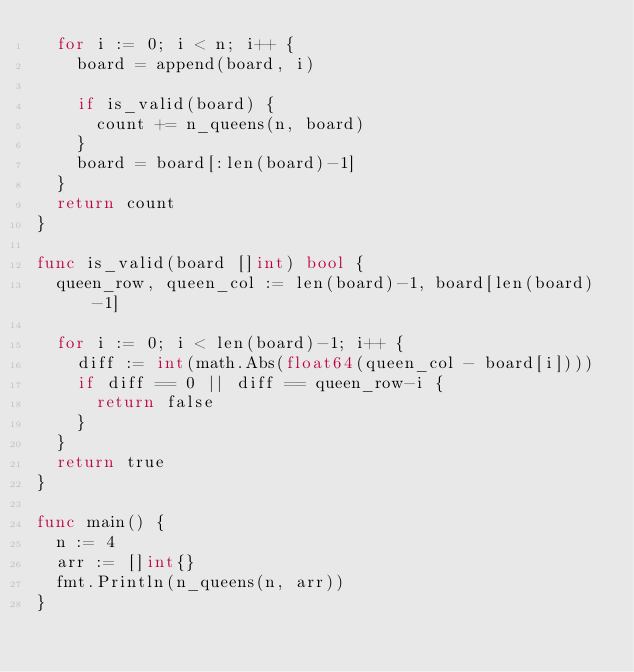<code> <loc_0><loc_0><loc_500><loc_500><_Go_>	for i := 0; i < n; i++ {
		board = append(board, i)

		if is_valid(board) {
			count += n_queens(n, board)
		}
		board = board[:len(board)-1]
	}
	return count
}

func is_valid(board []int) bool {
	queen_row, queen_col := len(board)-1, board[len(board)-1]

	for i := 0; i < len(board)-1; i++ {
		diff := int(math.Abs(float64(queen_col - board[i])))
		if diff == 0 || diff == queen_row-i {
			return false
		}
	}
	return true
}

func main() {
	n := 4
	arr := []int{}
	fmt.Println(n_queens(n, arr))
}
</code> 